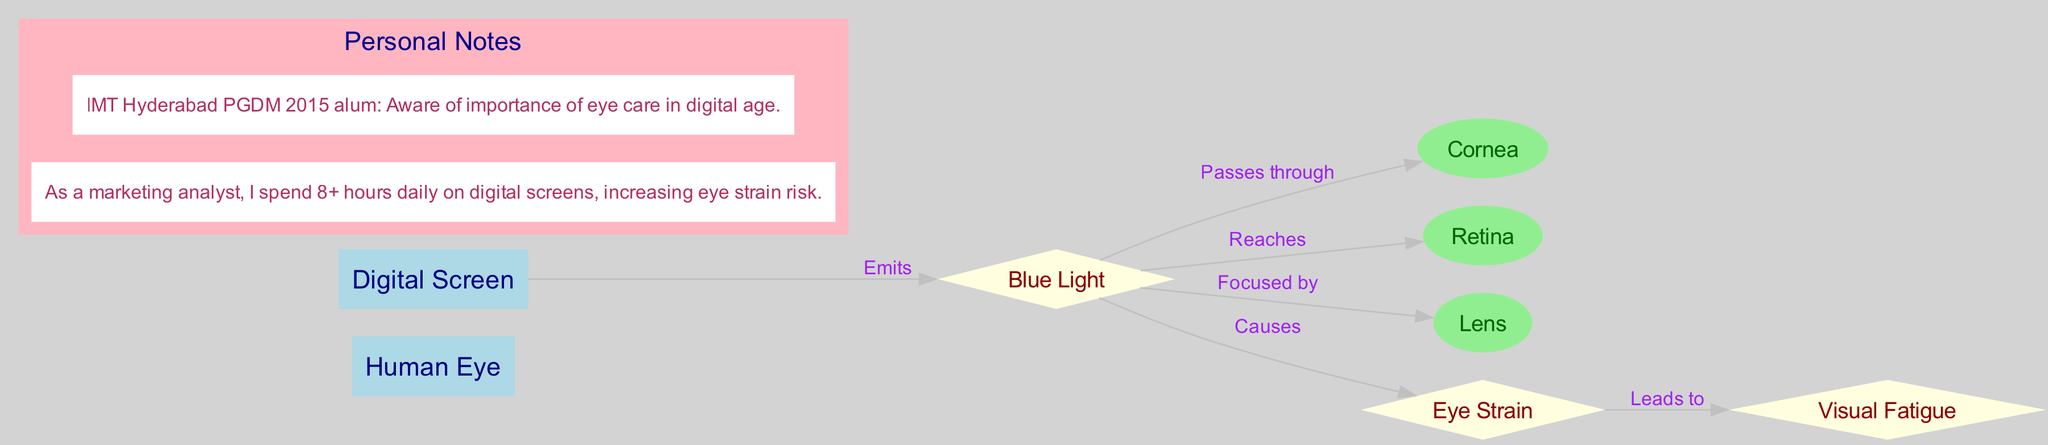What is the main focus of the diagram? The diagram illustrates the anatomical structure of the human eye and highlights the impact of digital screen exposure on eye strain and vision, indicated by connecting nodes and their relationships.
Answer: Human Eye and Digital Screen Exposure How many nodes are present in the diagram? By counting each unique entity described in the 'nodes' section, we find there are eight nodes: Human Eye, Cornea, Retina, Lens, Digital Screen, Blue Light, Eye Strain, Visual Fatigue.
Answer: 8 What causes eye strain according to the diagram? The edge labeled 'Causes' connects the node 'Blue Light' to the node 'Eye Strain', indicating that blue light is the factor that contributes to eye strain.
Answer: Blue Light Which node does the blue light pass through first? The connection 'Passes through' indicates that blue light first passes through the 'Cornea' before affecting other parts of the eye.
Answer: Cornea Which node is directly influenced by eye strain? The edge labeled 'Leads to' shows that 'Eye Strain' directly leads to 'Visual Fatigue', highlighting the progression from strain to fatigue.
Answer: Visual Fatigue What is emitted by the digital screen? The relationship 'Emits' connects the node 'Digital Screen' to 'Blue Light', identifying blue light as the output of digital screens.
Answer: Blue Light How does blue light affect the retina? The connection labeled 'Reaches' demonstrates that blue light travels from the lens to the retina, establishing a direct relationship regarding its impact.
Answer: Reaches What effect does digital screen time have on marketing analysts according to the annotations? One of the annotations states that marketing analysts spend over 8 hours daily on digital screens, suggesting an increased risk of eye strain.
Answer: Increased eye strain risk 